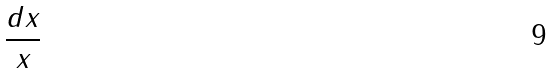<formula> <loc_0><loc_0><loc_500><loc_500>\frac { d x } { x }</formula> 